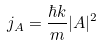<formula> <loc_0><loc_0><loc_500><loc_500>j _ { A } = \frac { \hbar { k } } { m } | A | ^ { 2 }</formula> 